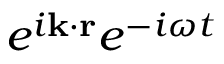<formula> <loc_0><loc_0><loc_500><loc_500>e ^ { i k \cdot r } e ^ { - i \omega t }</formula> 